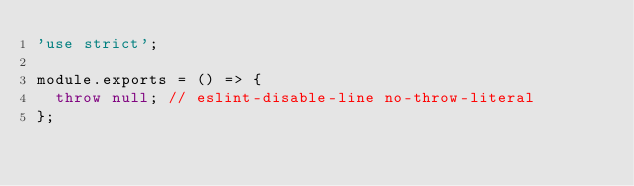Convert code to text. <code><loc_0><loc_0><loc_500><loc_500><_JavaScript_>'use strict';

module.exports = () => {
  throw null; // eslint-disable-line no-throw-literal
};
</code> 